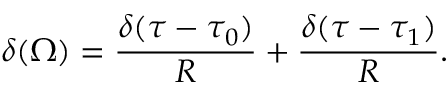<formula> <loc_0><loc_0><loc_500><loc_500>\delta ( \Omega ) = { \frac { \delta ( \tau - \tau _ { 0 } ) } { R } } + { \frac { \delta ( \tau - \tau _ { 1 } ) } { R } } .</formula> 